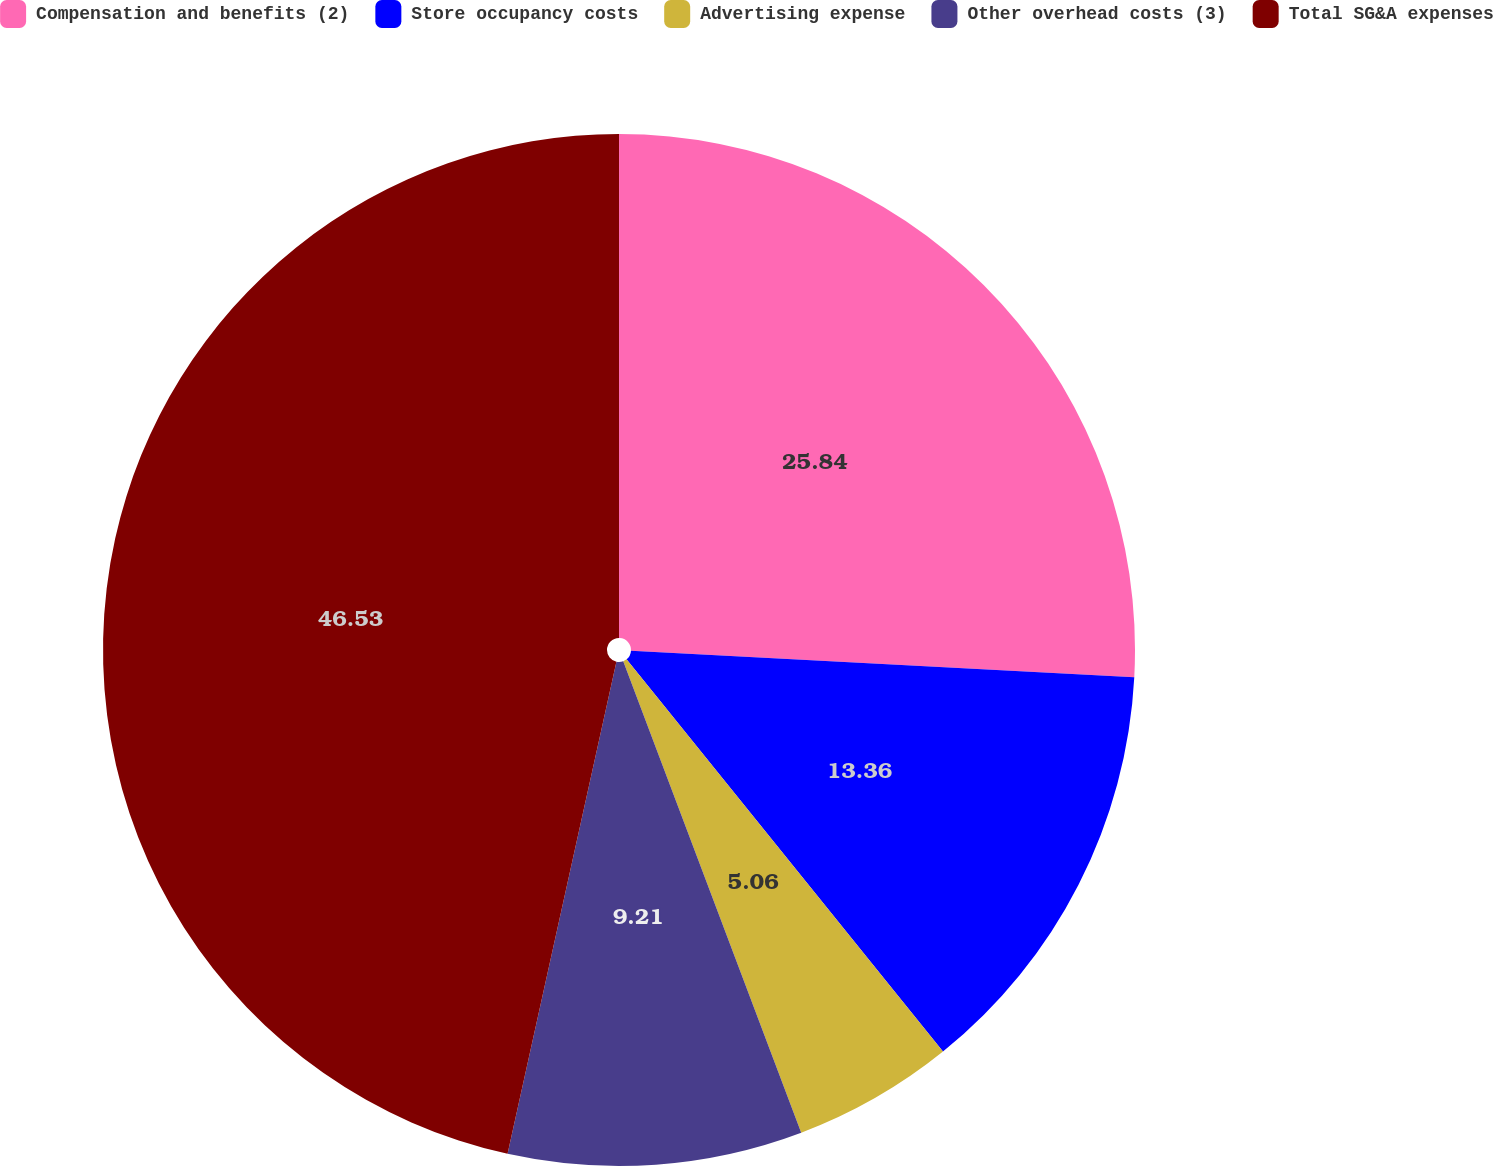<chart> <loc_0><loc_0><loc_500><loc_500><pie_chart><fcel>Compensation and benefits (2)<fcel>Store occupancy costs<fcel>Advertising expense<fcel>Other overhead costs (3)<fcel>Total SG&A expenses<nl><fcel>25.84%<fcel>13.36%<fcel>5.06%<fcel>9.21%<fcel>46.54%<nl></chart> 